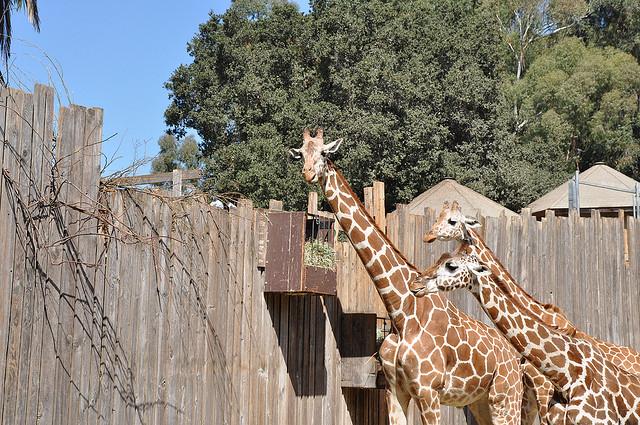Are there clouds in the sky?
Be succinct. No. How tall is the giraffe?
Be succinct. Very. Are these animals in a zoo?
Quick response, please. Yes. 